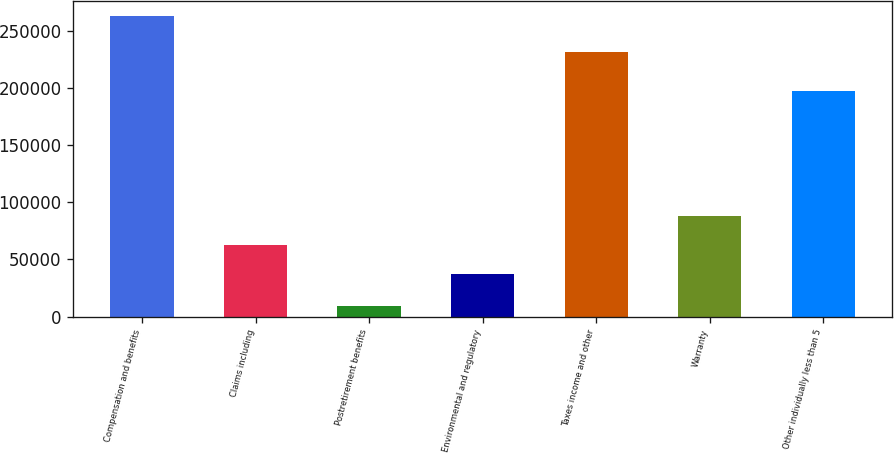Convert chart. <chart><loc_0><loc_0><loc_500><loc_500><bar_chart><fcel>Compensation and benefits<fcel>Claims including<fcel>Postretirement benefits<fcel>Environmental and regulatory<fcel>Taxes income and other<fcel>Warranty<fcel>Other individually less than 5<nl><fcel>262848<fcel>62505.8<fcel>9000<fcel>37121<fcel>231358<fcel>87890.6<fcel>197799<nl></chart> 